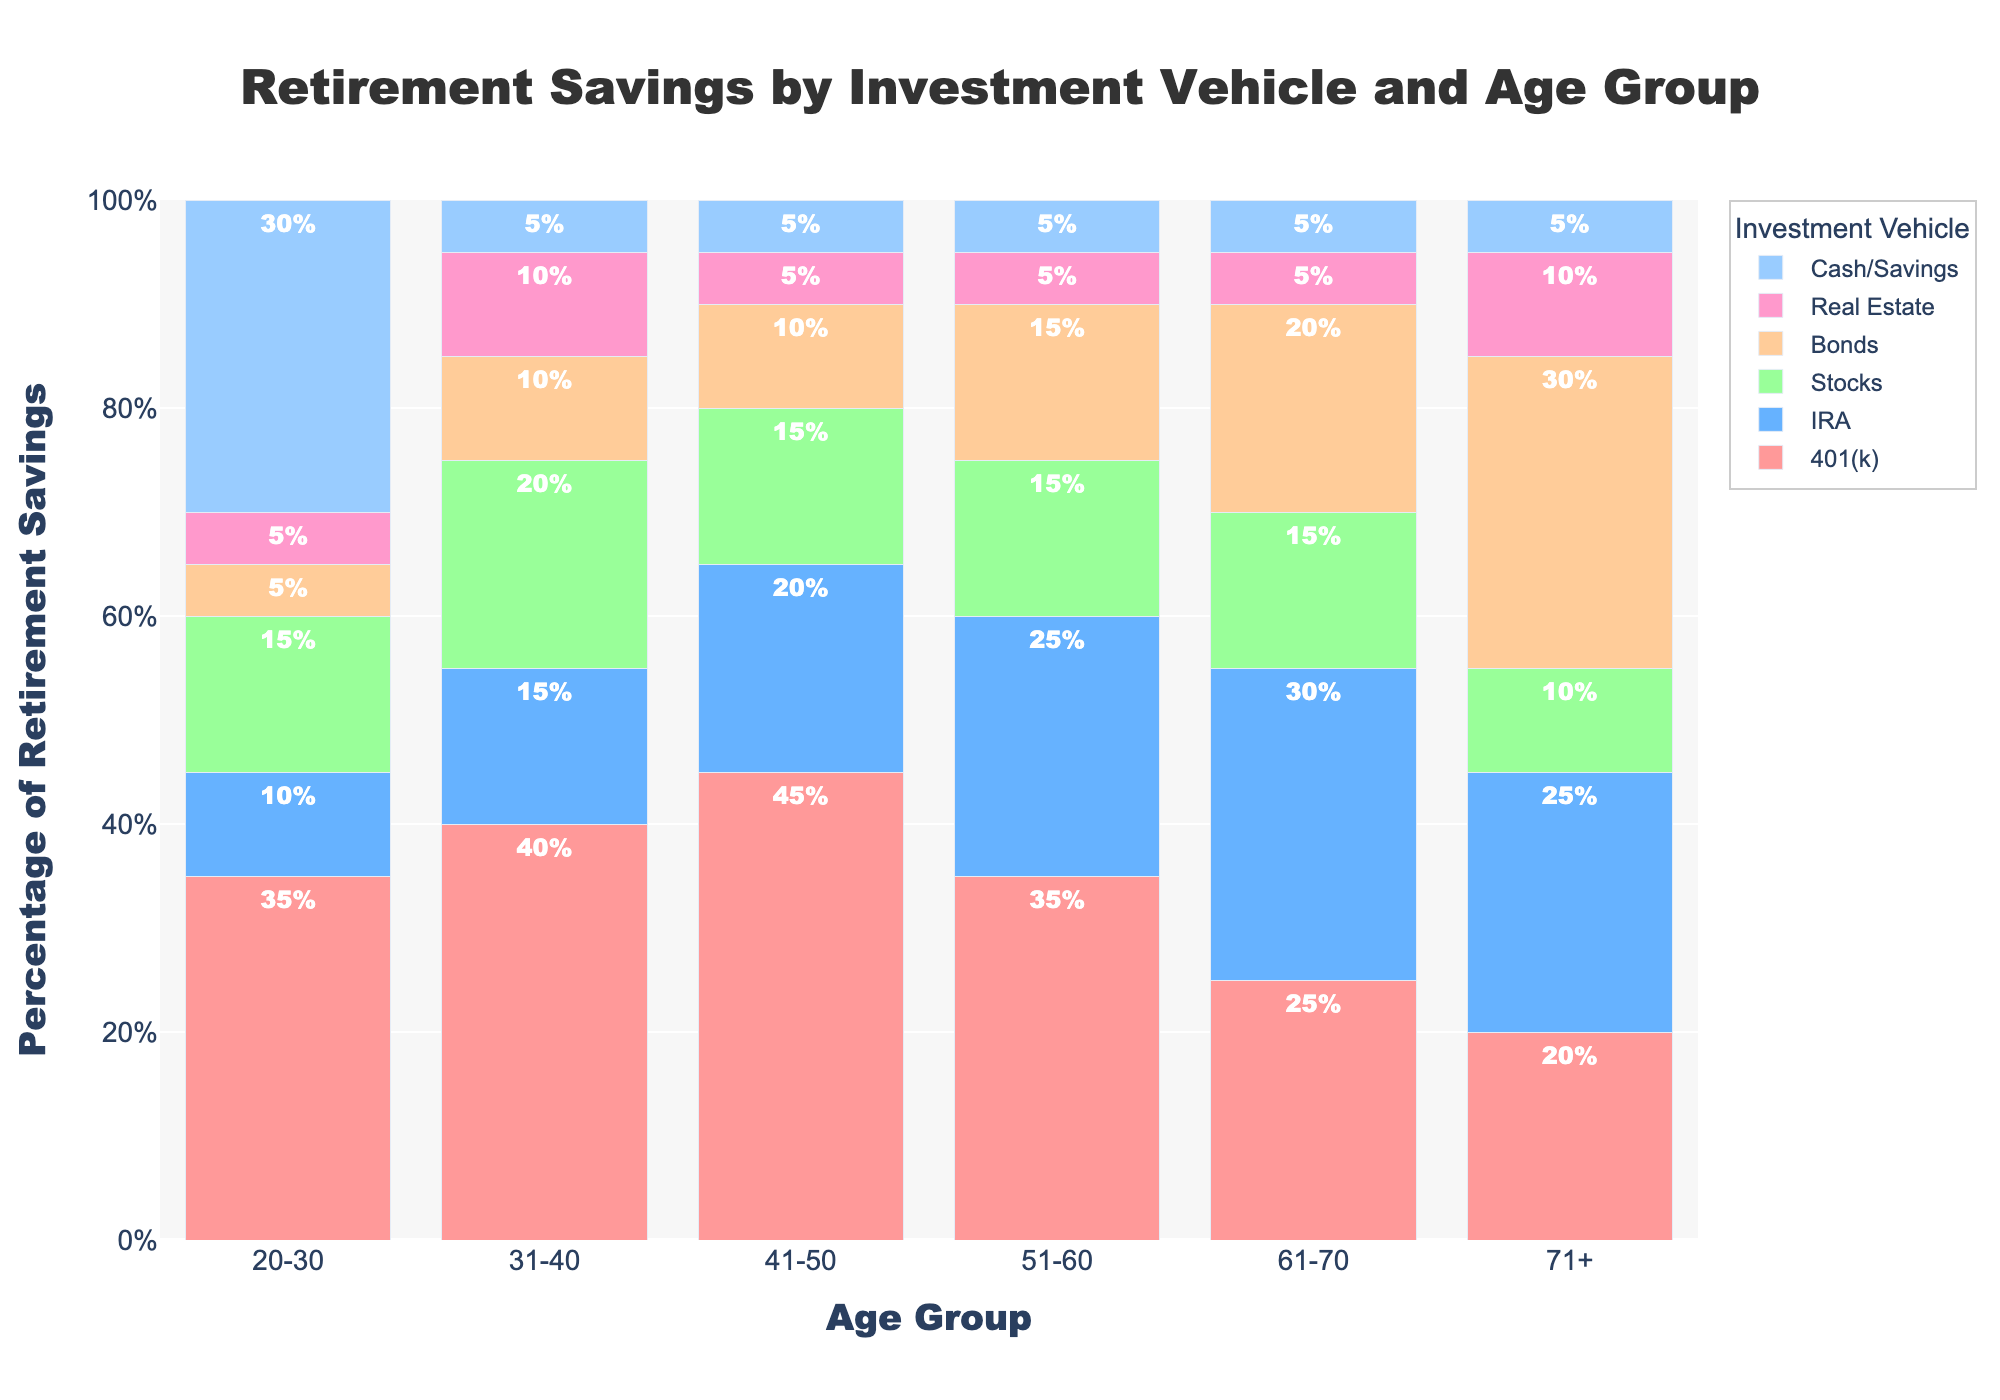What's the total percentage of retirement savings allocated to Real Estate across all age groups? To find the total percentage of retirement savings allocated to Real Estate, sum the percentages across all age groups: 5% (20-30) + 10% (31-40) + 5% (41-50) + 5% (51-60) + 5% (61-70) + 10% (71+). The total is 40%.
Answer: 40% Which age group shows the highest percentage allocation to Bonds? Look for the age group with the tallest bar segment in the color associated with Bonds. The age group 71+ has the highest percentage allocation to Bonds at 30%.
Answer: 71+ Compare the 401(k) percentage allocation between age group 20-30 and age group 31-40. Which age group has a higher allocation? Look at the heights of the 401(k) bar segments for these age groups. The percentage for 401(k) in age group 20-30 is 35%, while for age group 31-40, it's 40%. Hence, the 31-40 group has a higher allocation.
Answer: 31-40 Which investment vehicle has the greatest percentage allocation in the 61-70 age group? Identify the tallest bar segment in the 61-70 age group column. The tallest segment corresponds to IRA with a percentage allocation of 30%.
Answer: IRA What's the combined allocation percentage for Cash/Savings and Stocks in the 20-30 age group? Sum the percentage values for Cash/Savings and Stocks in the 20-30 age group: 30% (Cash/Savings) + 15% (Stocks) = 45%.
Answer: 45% Does the allocation percentage for IRA increase, decrease, or remain the same as the age groups progress? Observe the trend of the IRA bar segments across age groups. The percentage allocation to IRA follows an increasing trend from 20-30 to 61-70, then decreases for 71+.
Answer: Increase, then decrease What percentage difference is there between the highest and lowest allocations to 401(k) across all age groups? Identify the highest and lowest values for 401(k) which are 45% and 20%, respectively. The difference is 45% - 20% = 25%.
Answer: 25% What's the average percentage allocation of Cash/Savings across all age groups? Sum the percentage values of Cash/Savings across all age groups and divide by the number of age groups: (30 + 5 + 5 + 5 + 5 + 5)/6 = 55/6 ≈ 9.17%.
Answer: 9.17% Which age group has the smallest allocation to Stocks? Find the age group with the shortest bar segment in the color associated with Stocks. The 71+ age group has the smallest allocation to Stocks at 10%.
Answer: 71+ Is the percentage allocation to 401(k) higher for the 41-50 age group or the 51-60 age group? Compare the heights of the 401(k) bar segments for these age groups. The 41-50 age group has a 45% allocation, while the 51-60 age group has a 35% allocation. Therefore, the 41-50 group has the higher allocation.
Answer: 41-50 